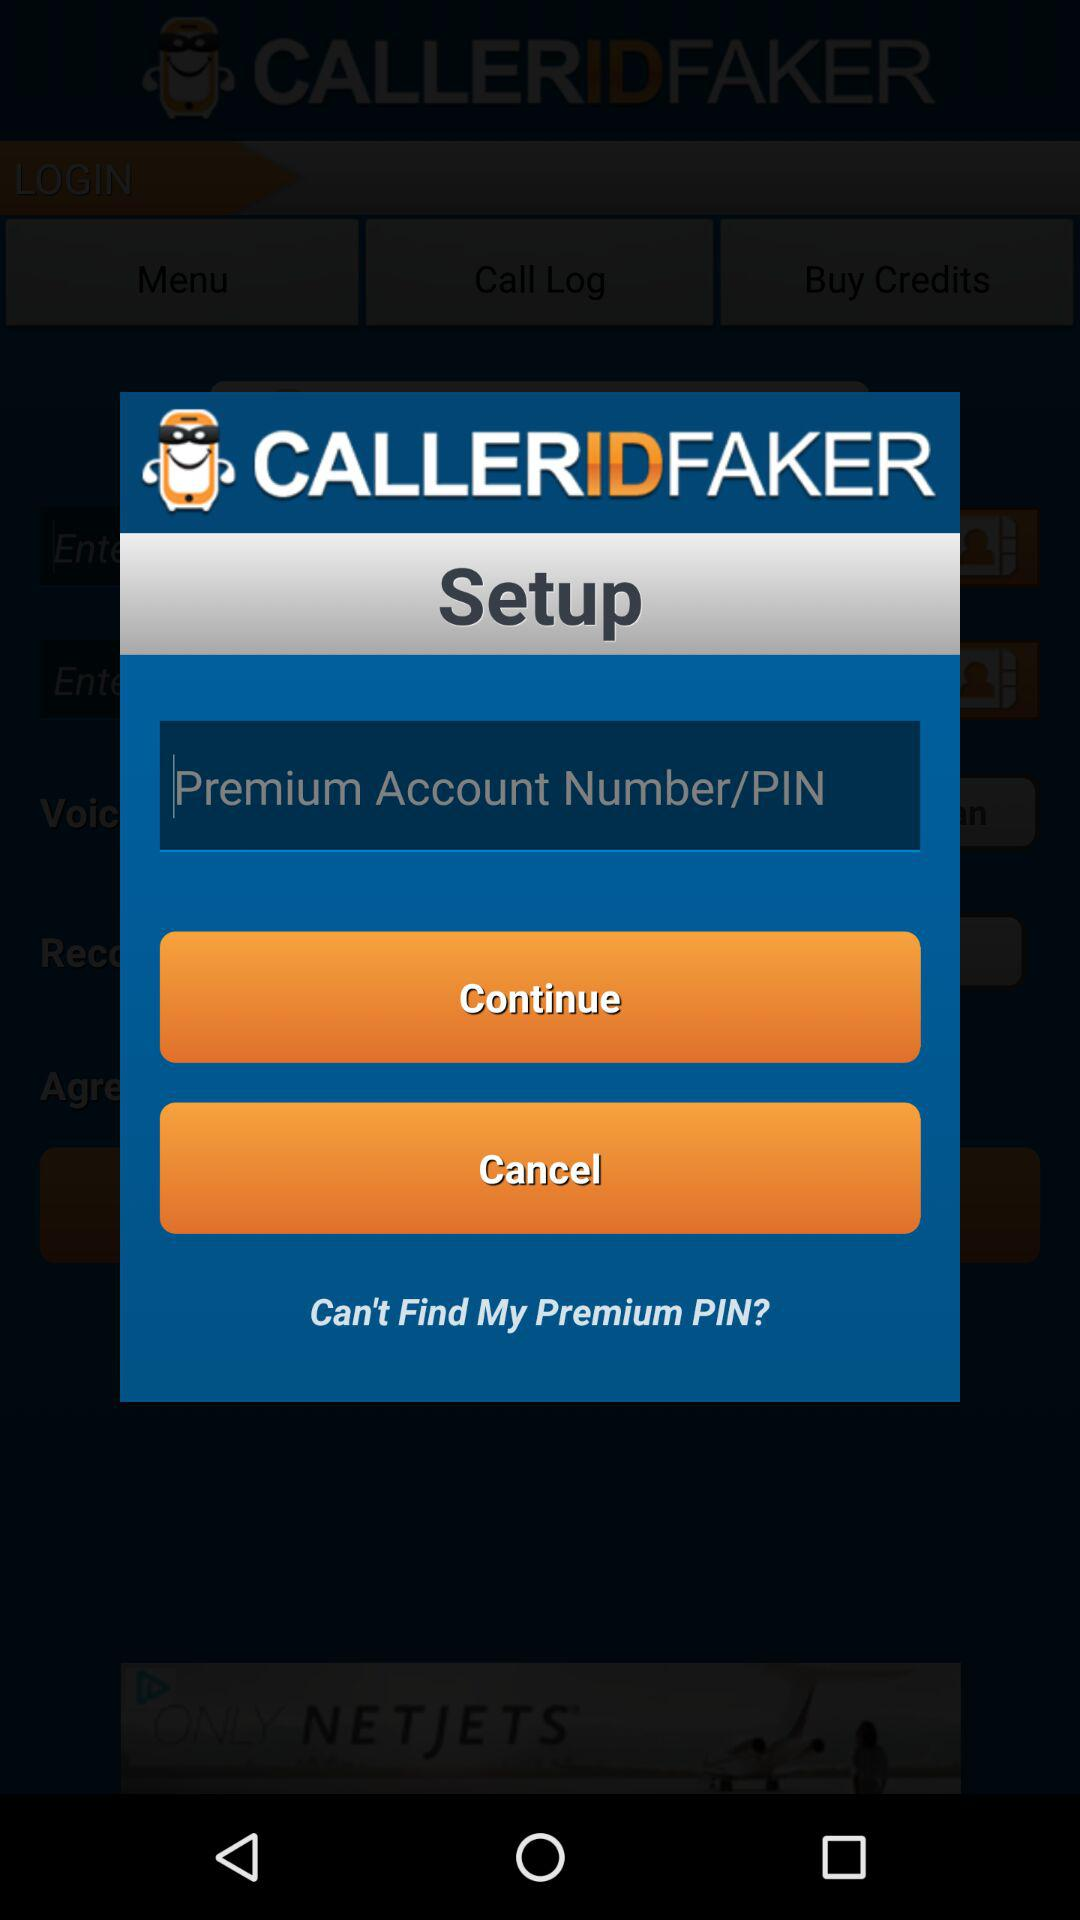What is the application name? The application name is "CALLERIDFAKER". 